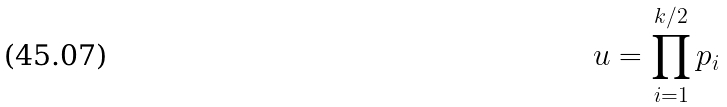<formula> <loc_0><loc_0><loc_500><loc_500>u = \prod _ { i = 1 } ^ { k / 2 } p _ { i }</formula> 